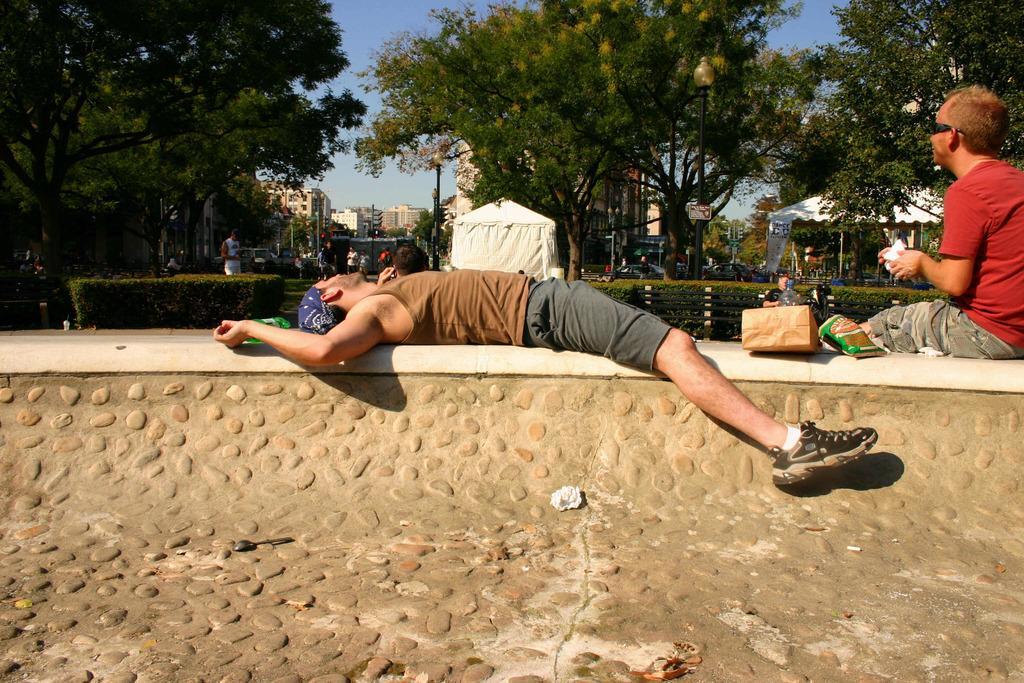Please provide a concise description of this image. In the center of the image a man is lying on a wall. On the right side of the image a man is sitting on a wall and we can see some packets, bottle are there. In the middle of the image we can see some bushes, tent, trees, light, pole, buildings are there. At the top of the image sky is there. At the bottom of the image wall is there. 